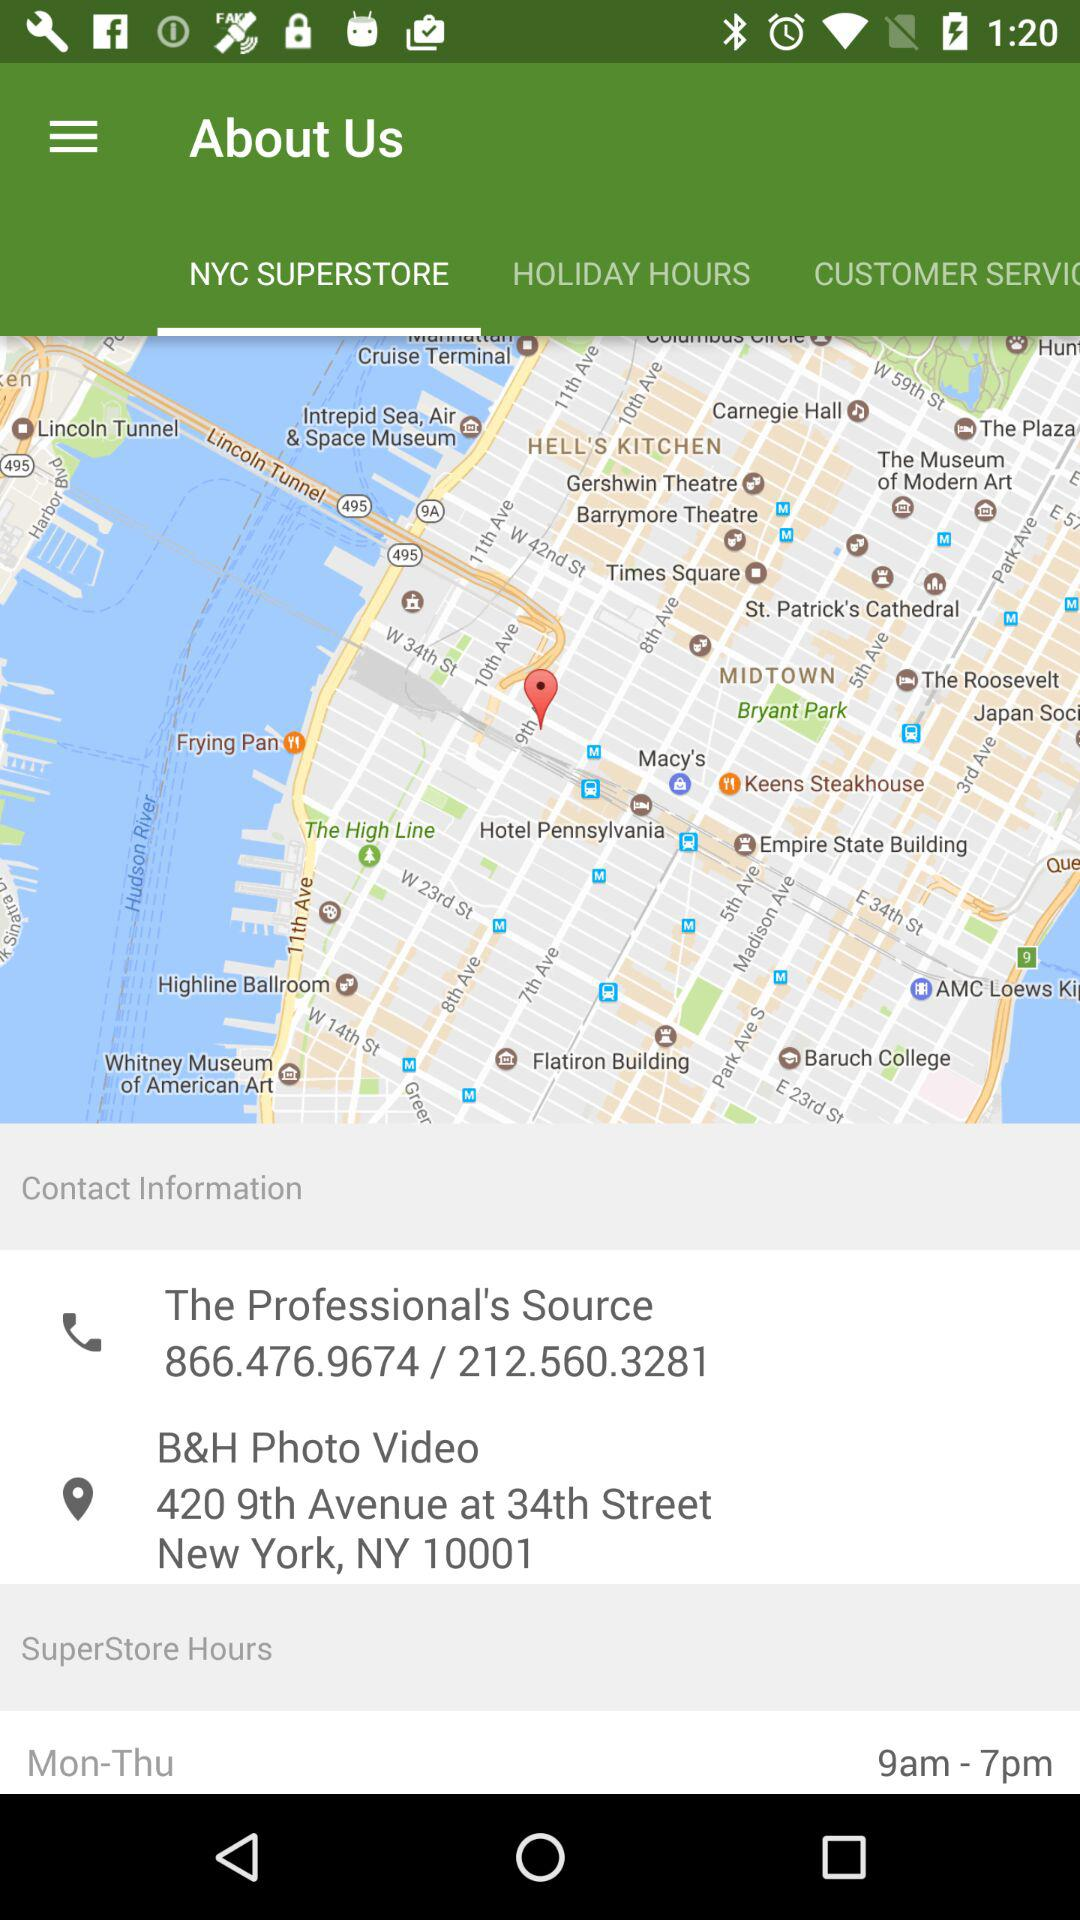What are the hours of operation of the superstore? The hours of operation of the superstore are from 9 a.m. to 7 p.m. 